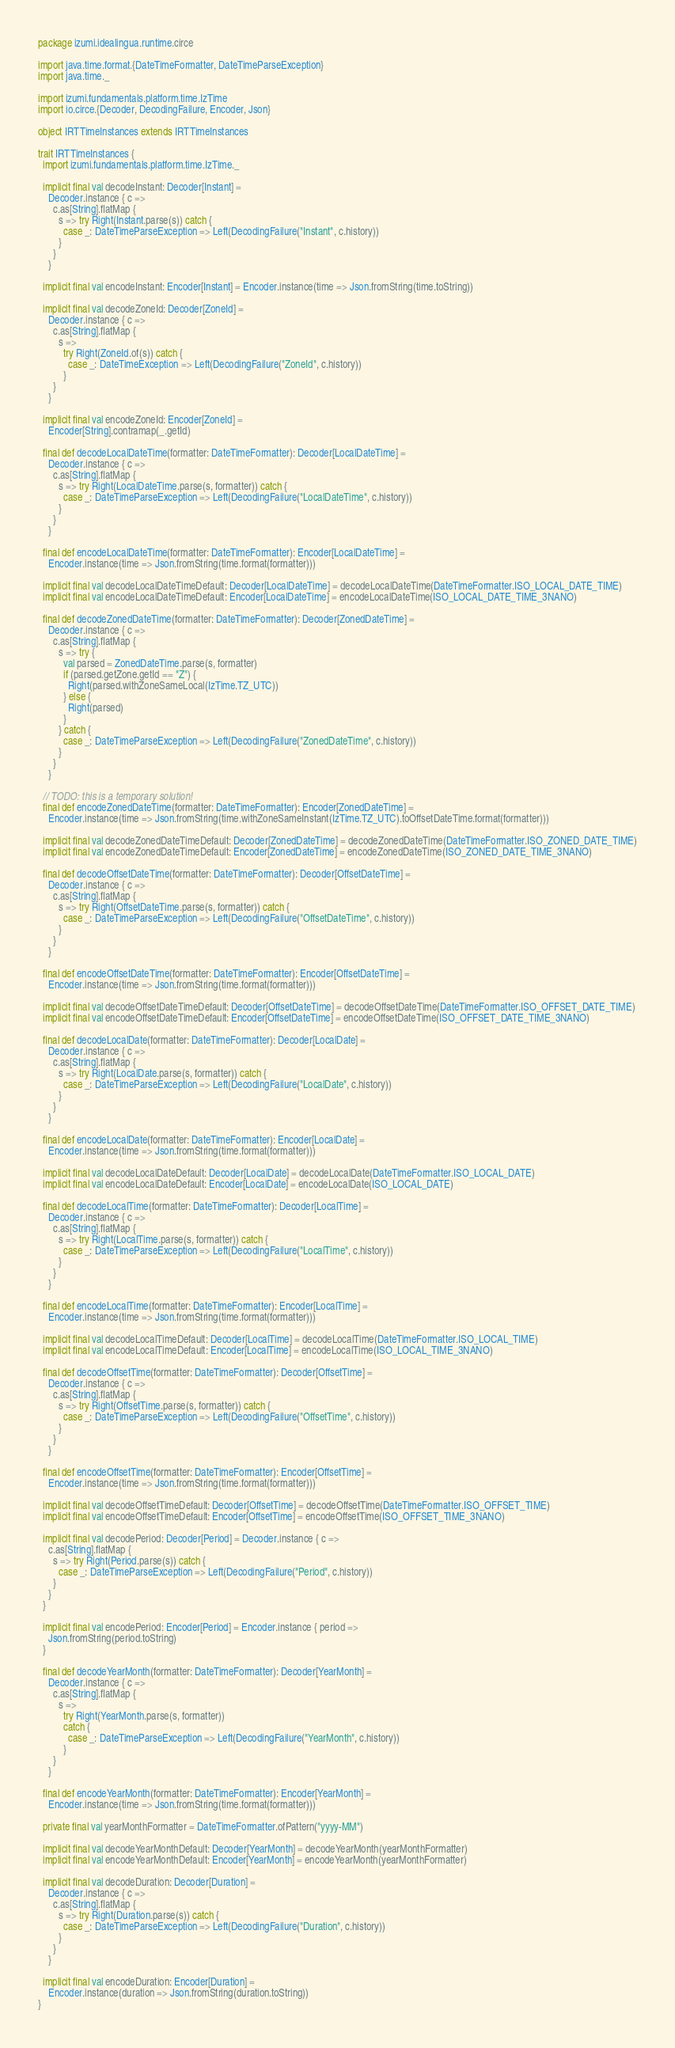<code> <loc_0><loc_0><loc_500><loc_500><_Scala_>package izumi.idealingua.runtime.circe

import java.time.format.{DateTimeFormatter, DateTimeParseException}
import java.time._

import izumi.fundamentals.platform.time.IzTime
import io.circe.{Decoder, DecodingFailure, Encoder, Json}

object IRTTimeInstances extends IRTTimeInstances

trait IRTTimeInstances {
  import izumi.fundamentals.platform.time.IzTime._

  implicit final val decodeInstant: Decoder[Instant] =
    Decoder.instance { c =>
      c.as[String].flatMap {
        s => try Right(Instant.parse(s)) catch {
          case _: DateTimeParseException => Left(DecodingFailure("Instant", c.history))
        }
      }
    }

  implicit final val encodeInstant: Encoder[Instant] = Encoder.instance(time => Json.fromString(time.toString))

  implicit final val decodeZoneId: Decoder[ZoneId] =
    Decoder.instance { c =>
      c.as[String].flatMap {
        s =>
          try Right(ZoneId.of(s)) catch {
            case _: DateTimeException => Left(DecodingFailure("ZoneId", c.history))
          }
      }
    }

  implicit final val encodeZoneId: Encoder[ZoneId] =
    Encoder[String].contramap(_.getId)

  final def decodeLocalDateTime(formatter: DateTimeFormatter): Decoder[LocalDateTime] =
    Decoder.instance { c =>
      c.as[String].flatMap {
        s => try Right(LocalDateTime.parse(s, formatter)) catch {
          case _: DateTimeParseException => Left(DecodingFailure("LocalDateTime", c.history))
        }
      }
    }

  final def encodeLocalDateTime(formatter: DateTimeFormatter): Encoder[LocalDateTime] =
    Encoder.instance(time => Json.fromString(time.format(formatter)))

  implicit final val decodeLocalDateTimeDefault: Decoder[LocalDateTime] = decodeLocalDateTime(DateTimeFormatter.ISO_LOCAL_DATE_TIME)
  implicit final val encodeLocalDateTimeDefault: Encoder[LocalDateTime] = encodeLocalDateTime(ISO_LOCAL_DATE_TIME_3NANO)

  final def decodeZonedDateTime(formatter: DateTimeFormatter): Decoder[ZonedDateTime] =
    Decoder.instance { c =>
      c.as[String].flatMap {
        s => try {
          val parsed = ZonedDateTime.parse(s, formatter)
          if (parsed.getZone.getId == "Z") {
            Right(parsed.withZoneSameLocal(IzTime.TZ_UTC))
          } else {
            Right(parsed)
          }
        } catch {
          case _: DateTimeParseException => Left(DecodingFailure("ZonedDateTime", c.history))
        }
      }
    }

  // TODO: this is a temporary solution!
  final def encodeZonedDateTime(formatter: DateTimeFormatter): Encoder[ZonedDateTime] =
    Encoder.instance(time => Json.fromString(time.withZoneSameInstant(IzTime.TZ_UTC).toOffsetDateTime.format(formatter)))

  implicit final val decodeZonedDateTimeDefault: Decoder[ZonedDateTime] = decodeZonedDateTime(DateTimeFormatter.ISO_ZONED_DATE_TIME)
  implicit final val encodeZonedDateTimeDefault: Encoder[ZonedDateTime] = encodeZonedDateTime(ISO_ZONED_DATE_TIME_3NANO)

  final def decodeOffsetDateTime(formatter: DateTimeFormatter): Decoder[OffsetDateTime] =
    Decoder.instance { c =>
      c.as[String].flatMap {
        s => try Right(OffsetDateTime.parse(s, formatter)) catch {
          case _: DateTimeParseException => Left(DecodingFailure("OffsetDateTime", c.history))
        }
      }
    }

  final def encodeOffsetDateTime(formatter: DateTimeFormatter): Encoder[OffsetDateTime] =
    Encoder.instance(time => Json.fromString(time.format(formatter)))

  implicit final val decodeOffsetDateTimeDefault: Decoder[OffsetDateTime] = decodeOffsetDateTime(DateTimeFormatter.ISO_OFFSET_DATE_TIME)
  implicit final val encodeOffsetDateTimeDefault: Encoder[OffsetDateTime] = encodeOffsetDateTime(ISO_OFFSET_DATE_TIME_3NANO)

  final def decodeLocalDate(formatter: DateTimeFormatter): Decoder[LocalDate] =
    Decoder.instance { c =>
      c.as[String].flatMap {
        s => try Right(LocalDate.parse(s, formatter)) catch {
          case _: DateTimeParseException => Left(DecodingFailure("LocalDate", c.history))
        }
      }
    }

  final def encodeLocalDate(formatter: DateTimeFormatter): Encoder[LocalDate] =
    Encoder.instance(time => Json.fromString(time.format(formatter)))

  implicit final val decodeLocalDateDefault: Decoder[LocalDate] = decodeLocalDate(DateTimeFormatter.ISO_LOCAL_DATE)
  implicit final val encodeLocalDateDefault: Encoder[LocalDate] = encodeLocalDate(ISO_LOCAL_DATE)

  final def decodeLocalTime(formatter: DateTimeFormatter): Decoder[LocalTime] =
    Decoder.instance { c =>
      c.as[String].flatMap {
        s => try Right(LocalTime.parse(s, formatter)) catch {
          case _: DateTimeParseException => Left(DecodingFailure("LocalTime", c.history))
        }
      }
    }

  final def encodeLocalTime(formatter: DateTimeFormatter): Encoder[LocalTime] =
    Encoder.instance(time => Json.fromString(time.format(formatter)))

  implicit final val decodeLocalTimeDefault: Decoder[LocalTime] = decodeLocalTime(DateTimeFormatter.ISO_LOCAL_TIME)
  implicit final val encodeLocalTimeDefault: Encoder[LocalTime] = encodeLocalTime(ISO_LOCAL_TIME_3NANO)

  final def decodeOffsetTime(formatter: DateTimeFormatter): Decoder[OffsetTime] =
    Decoder.instance { c =>
      c.as[String].flatMap {
        s => try Right(OffsetTime.parse(s, formatter)) catch {
          case _: DateTimeParseException => Left(DecodingFailure("OffsetTime", c.history))
        }
      }
    }

  final def encodeOffsetTime(formatter: DateTimeFormatter): Encoder[OffsetTime] =
    Encoder.instance(time => Json.fromString(time.format(formatter)))

  implicit final val decodeOffsetTimeDefault: Decoder[OffsetTime] = decodeOffsetTime(DateTimeFormatter.ISO_OFFSET_TIME)
  implicit final val encodeOffsetTimeDefault: Encoder[OffsetTime] = encodeOffsetTime(ISO_OFFSET_TIME_3NANO)

  implicit final val decodePeriod: Decoder[Period] = Decoder.instance { c =>
    c.as[String].flatMap {
      s => try Right(Period.parse(s)) catch {
        case _: DateTimeParseException => Left(DecodingFailure("Period", c.history))
      }
    }
  }

  implicit final val encodePeriod: Encoder[Period] = Encoder.instance { period =>
    Json.fromString(period.toString)
  }

  final def decodeYearMonth(formatter: DateTimeFormatter): Decoder[YearMonth] =
    Decoder.instance { c =>
      c.as[String].flatMap {
        s =>
          try Right(YearMonth.parse(s, formatter))
          catch {
            case _: DateTimeParseException => Left(DecodingFailure("YearMonth", c.history))
          }
      }
    }

  final def encodeYearMonth(formatter: DateTimeFormatter): Encoder[YearMonth] =
    Encoder.instance(time => Json.fromString(time.format(formatter)))

  private final val yearMonthFormatter = DateTimeFormatter.ofPattern("yyyy-MM")

  implicit final val decodeYearMonthDefault: Decoder[YearMonth] = decodeYearMonth(yearMonthFormatter)
  implicit final val encodeYearMonthDefault: Encoder[YearMonth] = encodeYearMonth(yearMonthFormatter)

  implicit final val decodeDuration: Decoder[Duration] =
    Decoder.instance { c =>
      c.as[String].flatMap {
        s => try Right(Duration.parse(s)) catch {
          case _: DateTimeParseException => Left(DecodingFailure("Duration", c.history))
        }
      }
    }

  implicit final val encodeDuration: Encoder[Duration] =
    Encoder.instance(duration => Json.fromString(duration.toString))
}
</code> 